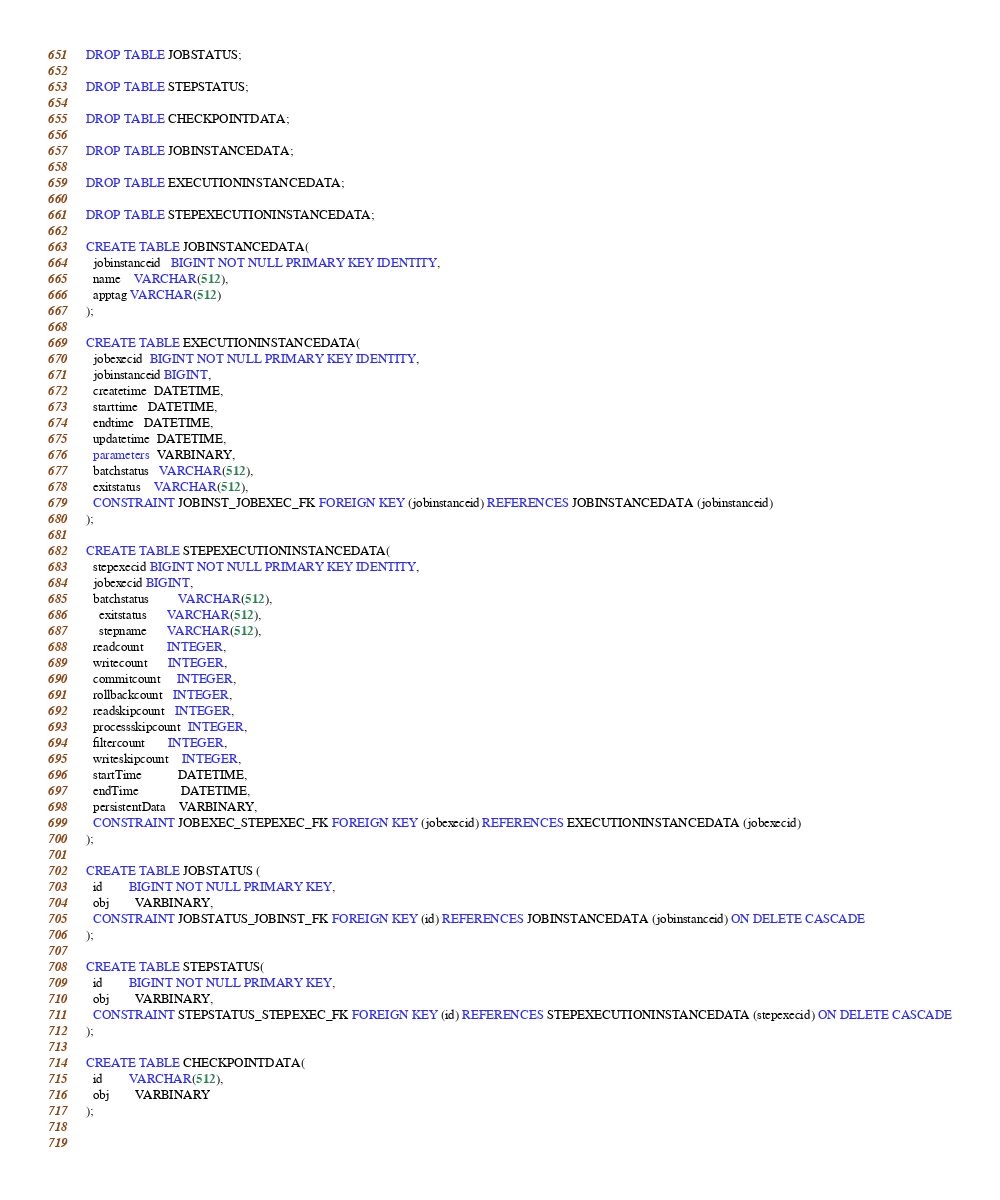Convert code to text. <code><loc_0><loc_0><loc_500><loc_500><_SQL_>
DROP TABLE JOBSTATUS;

DROP TABLE STEPSTATUS;

DROP TABLE CHECKPOINTDATA;

DROP TABLE JOBINSTANCEDATA;

DROP TABLE EXECUTIONINSTANCEDATA;

DROP TABLE STEPEXECUTIONINSTANCEDATA;

CREATE TABLE JOBINSTANCEDATA(
  jobinstanceid   BIGINT NOT NULL PRIMARY KEY IDENTITY,
  name    VARCHAR(512), 
  apptag VARCHAR(512)
);

CREATE TABLE EXECUTIONINSTANCEDATA(
  jobexecid  BIGINT NOT NULL PRIMARY KEY IDENTITY, 
  jobinstanceid BIGINT,
  createtime  DATETIME,
  starttime   DATETIME,
  endtime   DATETIME,
  updatetime  DATETIME,
  parameters  VARBINARY,
  batchstatus   VARCHAR(512),
  exitstatus    VARCHAR(512),
  CONSTRAINT JOBINST_JOBEXEC_FK FOREIGN KEY (jobinstanceid) REFERENCES JOBINSTANCEDATA (jobinstanceid)
);

CREATE TABLE STEPEXECUTIONINSTANCEDATA(
  stepexecid BIGINT NOT NULL PRIMARY KEY IDENTITY, 
  jobexecid BIGINT,
  batchstatus         VARCHAR(512),
    exitstatus      VARCHAR(512),
    stepname      VARCHAR(512),
  readcount       INTEGER,
  writecount      INTEGER,
  commitcount     INTEGER,
  rollbackcount   INTEGER,
  readskipcount   INTEGER,
  processskipcount  INTEGER,
  filtercount       INTEGER,
  writeskipcount    INTEGER,
  startTime           DATETIME,
  endTime             DATETIME,
  persistentData    VARBINARY,
  CONSTRAINT JOBEXEC_STEPEXEC_FK FOREIGN KEY (jobexecid) REFERENCES EXECUTIONINSTANCEDATA (jobexecid)
);  

CREATE TABLE JOBSTATUS (
  id		BIGINT NOT NULL PRIMARY KEY,
  obj		VARBINARY,
  CONSTRAINT JOBSTATUS_JOBINST_FK FOREIGN KEY (id) REFERENCES JOBINSTANCEDATA (jobinstanceid) ON DELETE CASCADE
);

CREATE TABLE STEPSTATUS(
  id		BIGINT NOT NULL PRIMARY KEY,
  obj		VARBINARY,
  CONSTRAINT STEPSTATUS_STEPEXEC_FK FOREIGN KEY (id) REFERENCES STEPEXECUTIONINSTANCEDATA (stepexecid) ON DELETE CASCADE
);

CREATE TABLE CHECKPOINTDATA(
  id		VARCHAR(512),
  obj		VARBINARY
);

  
</code> 